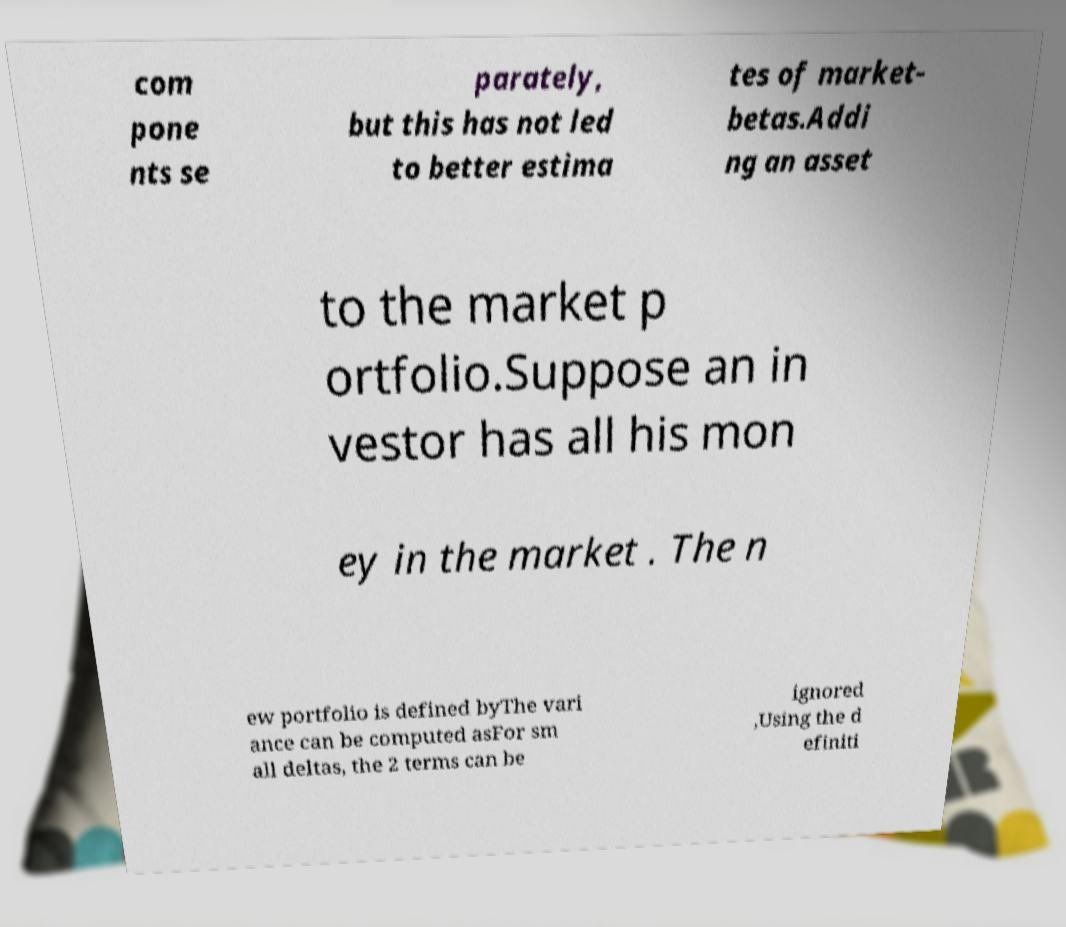What messages or text are displayed in this image? I need them in a readable, typed format. com pone nts se parately, but this has not led to better estima tes of market- betas.Addi ng an asset to the market p ortfolio.Suppose an in vestor has all his mon ey in the market . The n ew portfolio is defined byThe vari ance can be computed asFor sm all deltas, the 2 terms can be ignored ,Using the d efiniti 